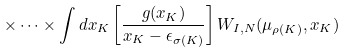Convert formula to latex. <formula><loc_0><loc_0><loc_500><loc_500>\times \dots \times \int d x _ { K } \left [ \frac { g ( x _ { K } ) } { x _ { K } - \epsilon _ { \sigma ( K ) } } \right ] W _ { I , N } ( \mu _ { \rho ( K ) } , x _ { K } )</formula> 